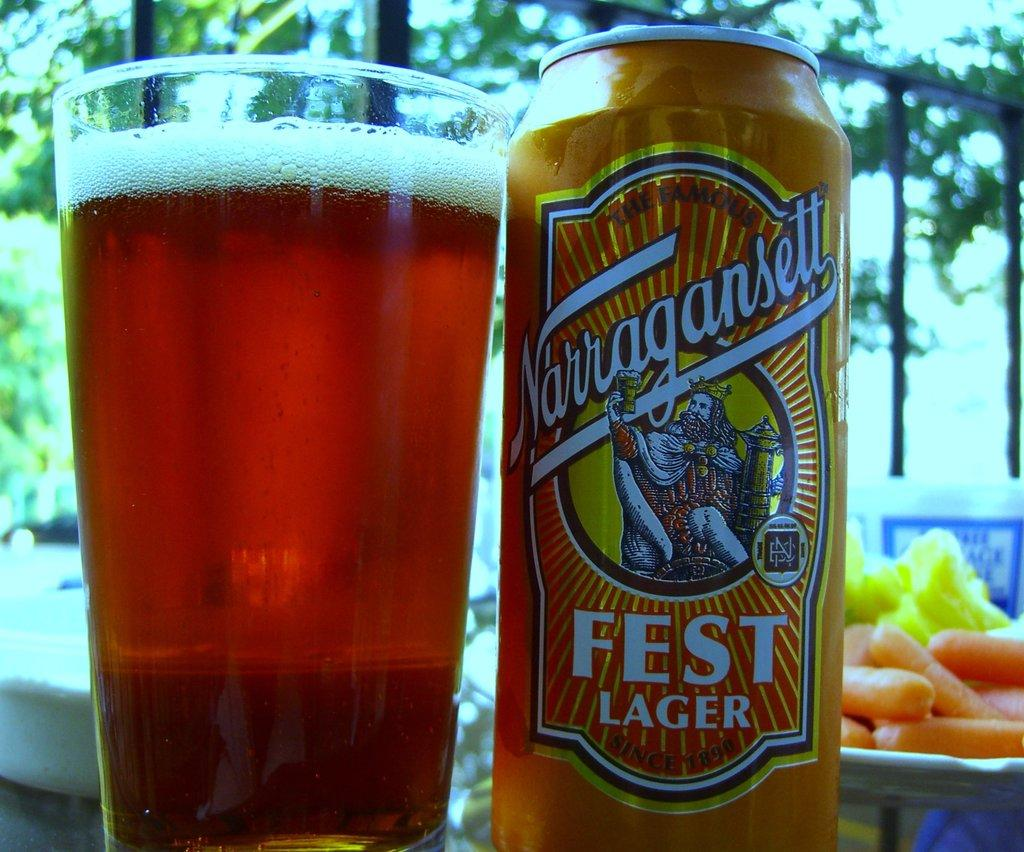Provide a one-sentence caption for the provided image. A can of Fest Lager sitting next to a glass. 